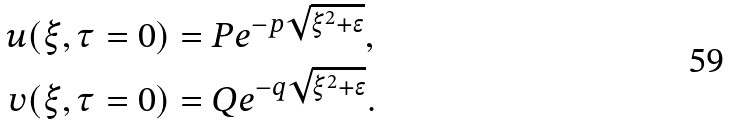Convert formula to latex. <formula><loc_0><loc_0><loc_500><loc_500>u ( \xi , \tau & = 0 ) = P e ^ { - p \sqrt { \xi ^ { 2 } + \epsilon } } , \\ v ( \xi , \tau & = 0 ) = Q e ^ { - q \sqrt { \xi ^ { 2 } + \epsilon } } .</formula> 